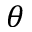Convert formula to latex. <formula><loc_0><loc_0><loc_500><loc_500>\theta</formula> 